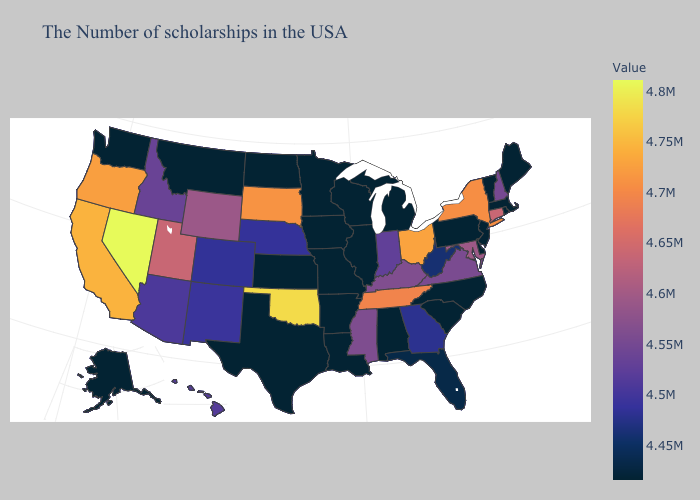Does Georgia have the highest value in the USA?
Be succinct. No. Among the states that border Pennsylvania , which have the lowest value?
Keep it brief. New Jersey, Delaware. Among the states that border Texas , which have the highest value?
Answer briefly. Oklahoma. Among the states that border Utah , which have the lowest value?
Write a very short answer. Colorado. 